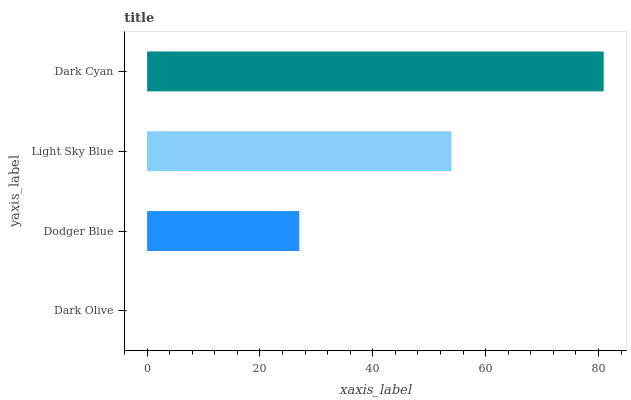Is Dark Olive the minimum?
Answer yes or no. Yes. Is Dark Cyan the maximum?
Answer yes or no. Yes. Is Dodger Blue the minimum?
Answer yes or no. No. Is Dodger Blue the maximum?
Answer yes or no. No. Is Dodger Blue greater than Dark Olive?
Answer yes or no. Yes. Is Dark Olive less than Dodger Blue?
Answer yes or no. Yes. Is Dark Olive greater than Dodger Blue?
Answer yes or no. No. Is Dodger Blue less than Dark Olive?
Answer yes or no. No. Is Light Sky Blue the high median?
Answer yes or no. Yes. Is Dodger Blue the low median?
Answer yes or no. Yes. Is Dark Cyan the high median?
Answer yes or no. No. Is Light Sky Blue the low median?
Answer yes or no. No. 